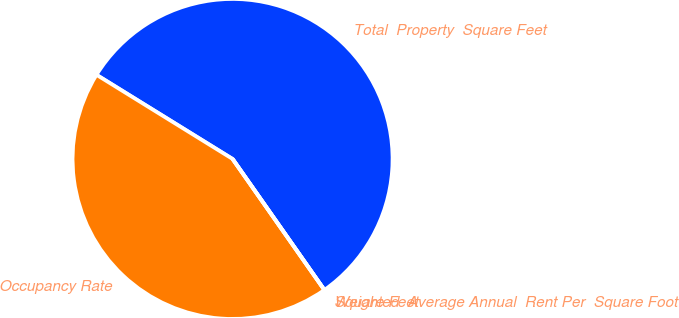Convert chart. <chart><loc_0><loc_0><loc_500><loc_500><pie_chart><fcel>Total  Property  Square Feet<fcel>Occupancy Rate<fcel>Weighted  Average Annual  Rent Per  Square Foot<fcel>Square Feet<nl><fcel>56.46%<fcel>43.54%<fcel>0.0%<fcel>0.0%<nl></chart> 